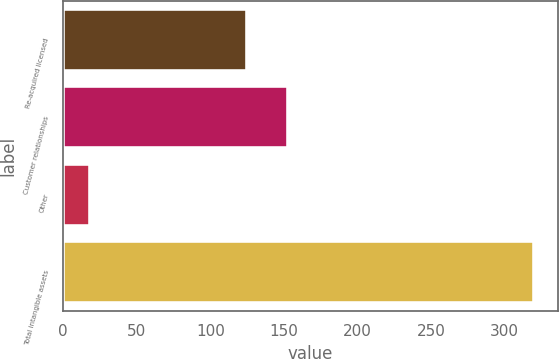Convert chart to OTSL. <chart><loc_0><loc_0><loc_500><loc_500><bar_chart><fcel>Re-acquired licensed<fcel>Customer relationships<fcel>Other<fcel>Total intangible assets<nl><fcel>125<fcel>153.1<fcel>18<fcel>320.1<nl></chart> 